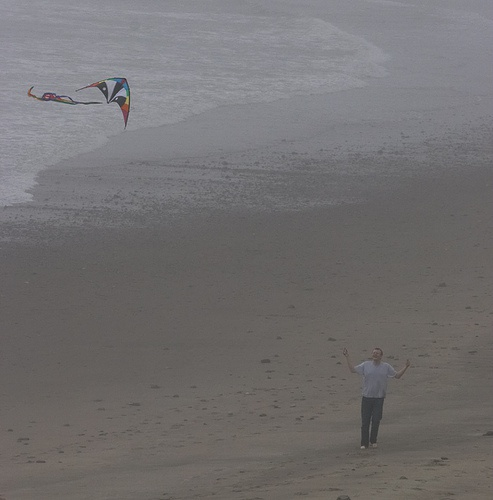Describe the objects in this image and their specific colors. I can see people in gray and black tones and kite in gray, darkgray, purple, and brown tones in this image. 